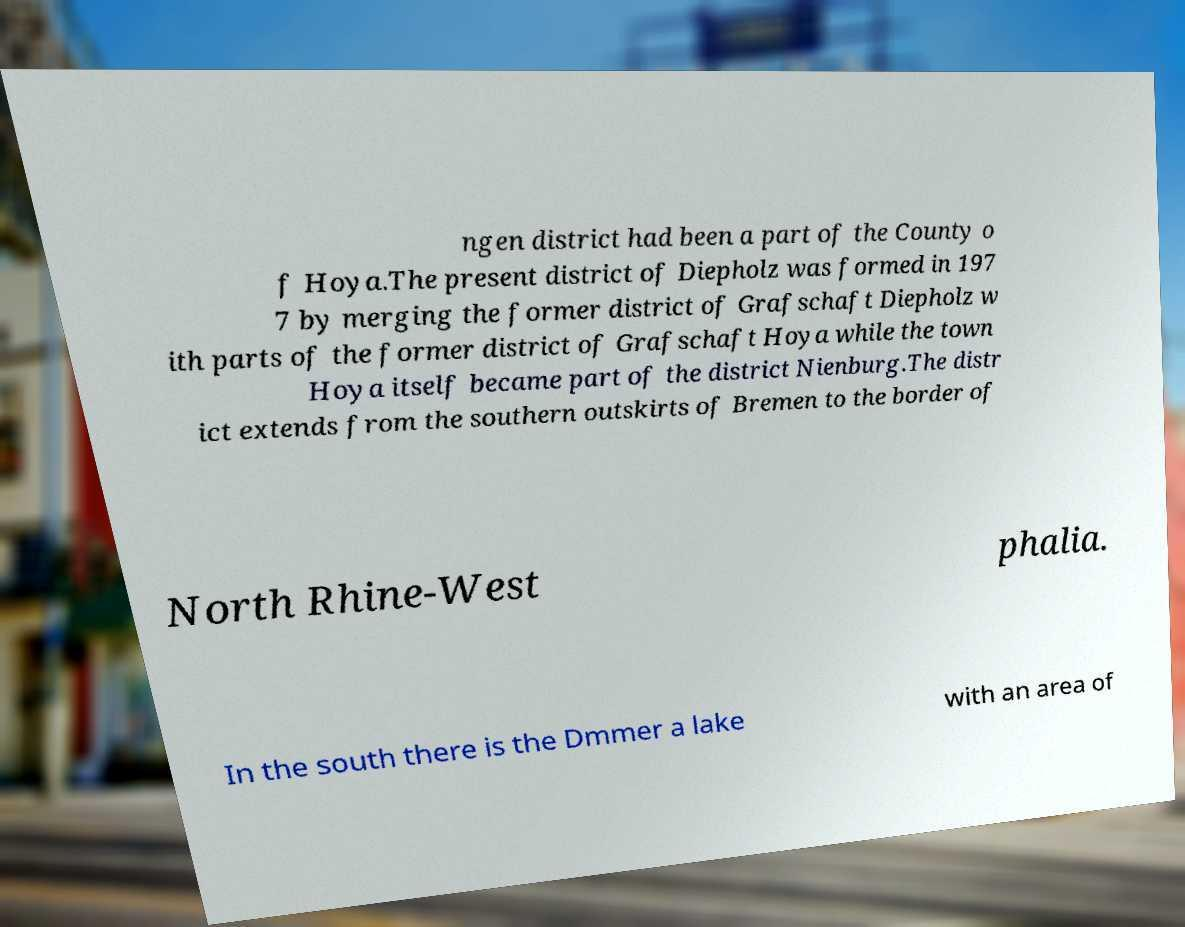Could you extract and type out the text from this image? ngen district had been a part of the County o f Hoya.The present district of Diepholz was formed in 197 7 by merging the former district of Grafschaft Diepholz w ith parts of the former district of Grafschaft Hoya while the town Hoya itself became part of the district Nienburg.The distr ict extends from the southern outskirts of Bremen to the border of North Rhine-West phalia. In the south there is the Dmmer a lake with an area of 